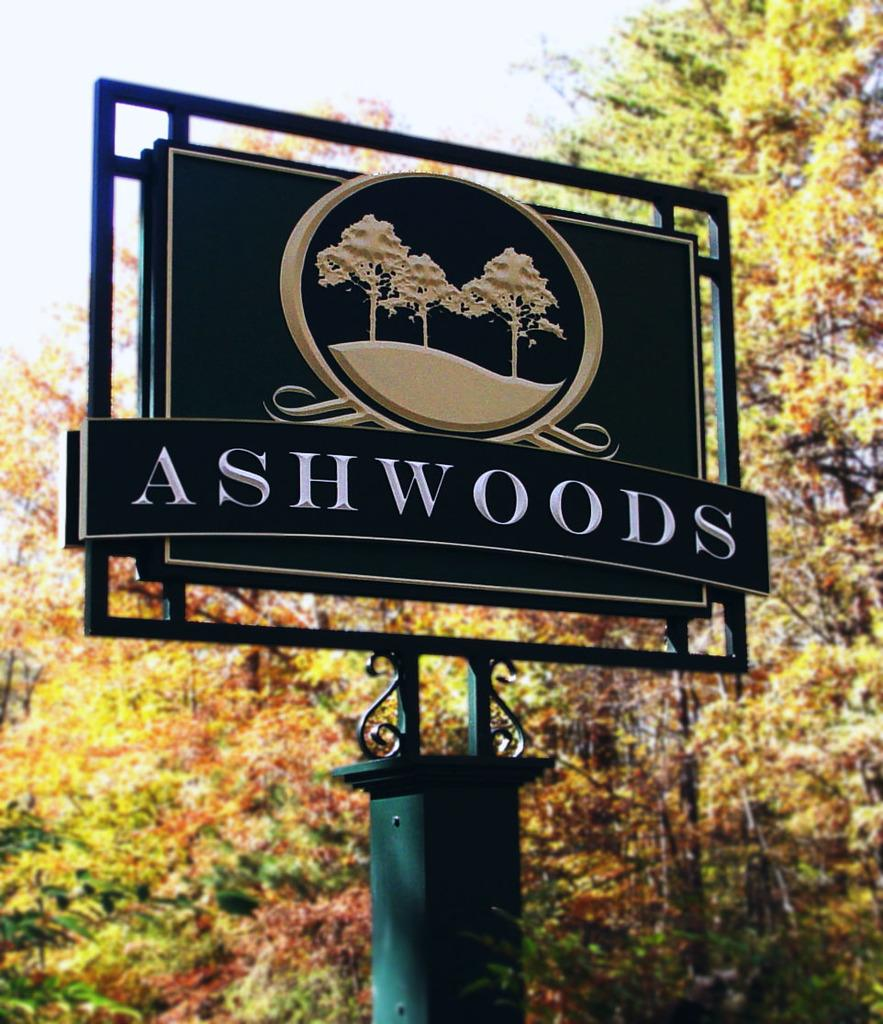What is attached to the pillar in the image? There is a board attached to a pillar in the image. What can be seen in the background of the image? There are trees visible in the background of the image. What type of grain is being harvested by the crow in the image? There is no crow or grain present in the image. What is the reaction of the people in the image to the board on the pillar? There are no people present in the image, so it is not possible to determine their reaction to the board on the pillar. 